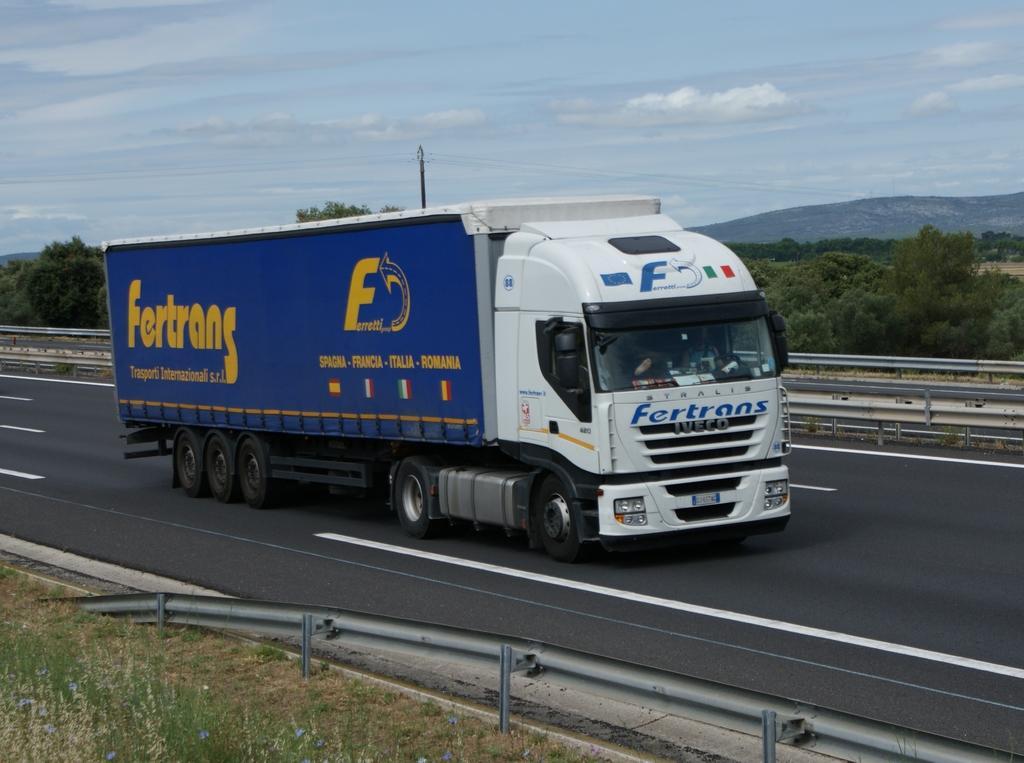Can you describe this image briefly? In this image we can see a vehicle on the road. Here we can see railing, grass, trees, pole, and mountain. In the background there is sky with clouds. 